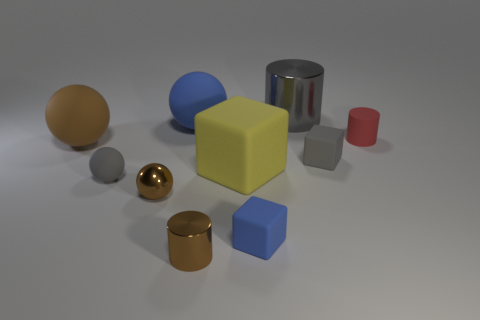Subtract all brown spheres. How many were subtracted if there are1brown spheres left? 1 Subtract all small brown balls. How many balls are left? 3 Subtract all gray spheres. How many spheres are left? 3 Subtract all cylinders. How many objects are left? 7 Subtract 2 cylinders. How many cylinders are left? 1 Subtract all small blocks. Subtract all cylinders. How many objects are left? 5 Add 7 small balls. How many small balls are left? 9 Add 6 small blue matte cubes. How many small blue matte cubes exist? 7 Subtract 0 purple cylinders. How many objects are left? 10 Subtract all yellow cubes. Subtract all blue cylinders. How many cubes are left? 2 